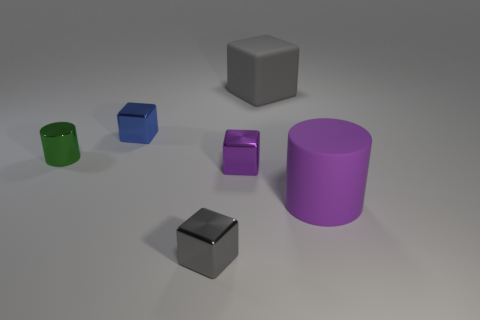What shape are the metallic objects in the center of the image? The metallic objects in the center of the image are both cubic. One is larger and has a reflective metallic finish, while the other is smaller with a purple hue and a slightly less reflective surface. Do these cubes reflect the environment in the image? Yes, the metallic surfaces of the cubes reflect the surroundings to some extent. The larger cube displays clear reflections on its sides, showing the light source and hints of other objects in the image, while the smaller purple cube's reflections are less distinct but still noticeable. 